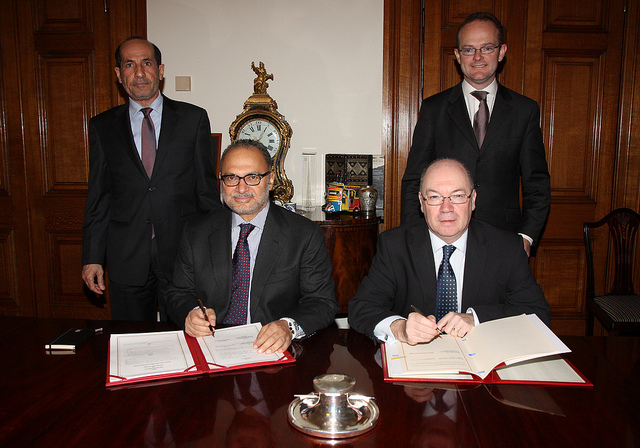Can you describe the setting and the mood of this event shown in the image? The image shows a formal setting with individuals wearing business attire. They appear to be participating in a significant event, possibly a contractual agreement or a professional meeting, given the presence of documents and pens on the table. The mood seems earnest and focused, with an undertone of importance given the seriousness of their expressions and the formal posture of all the participants. 